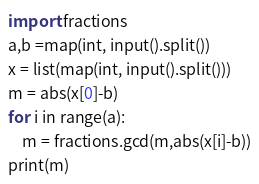Convert code to text. <code><loc_0><loc_0><loc_500><loc_500><_Python_>import fractions
a,b =map(int, input().split())
x = list(map(int, input().split()))
m = abs(x[0]-b)
for i in range(a):
    m = fractions.gcd(m,abs(x[i]-b))
print(m)</code> 